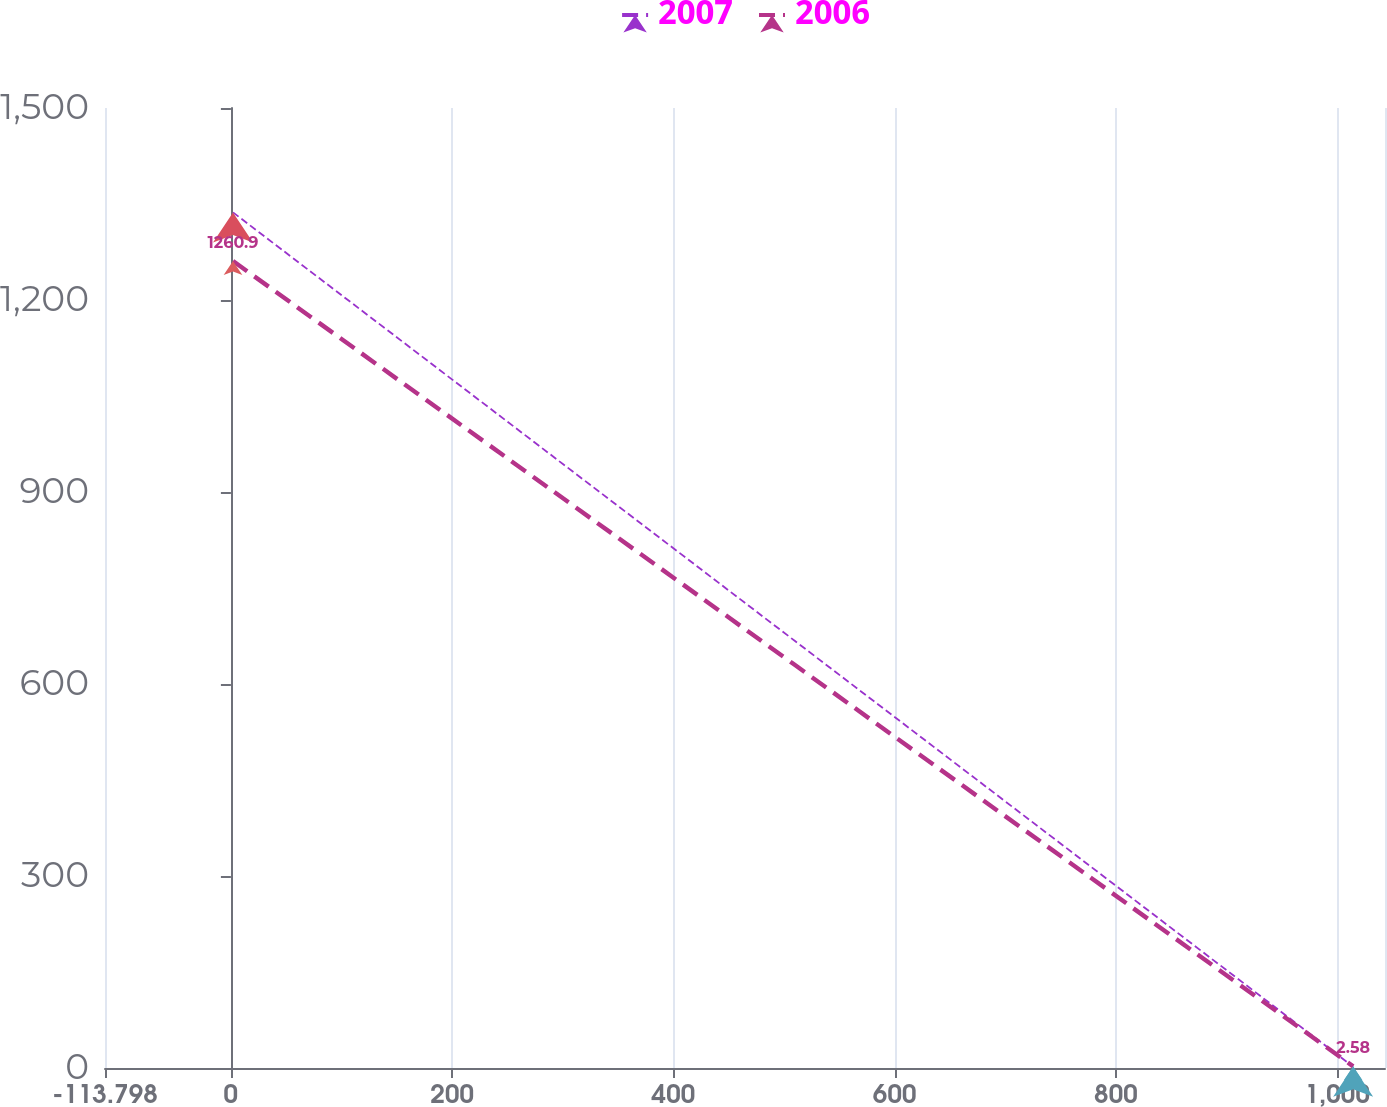Convert chart. <chart><loc_0><loc_0><loc_500><loc_500><line_chart><ecel><fcel>2007<fcel>2006<nl><fcel>1.9<fcel>1336.91<fcel>1260.9<nl><fcel>1014.39<fcel>1.99<fcel>2.58<nl><fcel>1158.88<fcel>1012<fcel>985.87<nl></chart> 